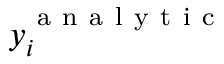<formula> <loc_0><loc_0><loc_500><loc_500>y _ { i } ^ { a n a l y t i c }</formula> 